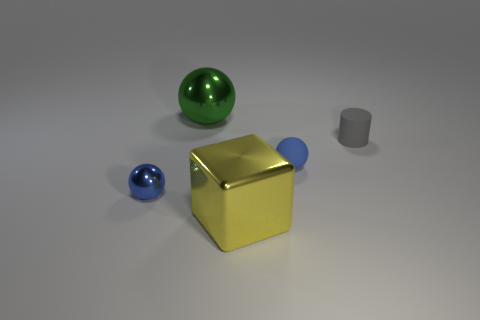Add 1 yellow metal cubes. How many objects exist? 6 Subtract all cylinders. How many objects are left? 4 Add 2 big cyan matte blocks. How many big cyan matte blocks exist? 2 Subtract 0 cyan spheres. How many objects are left? 5 Subtract all big yellow things. Subtract all balls. How many objects are left? 1 Add 1 yellow blocks. How many yellow blocks are left? 2 